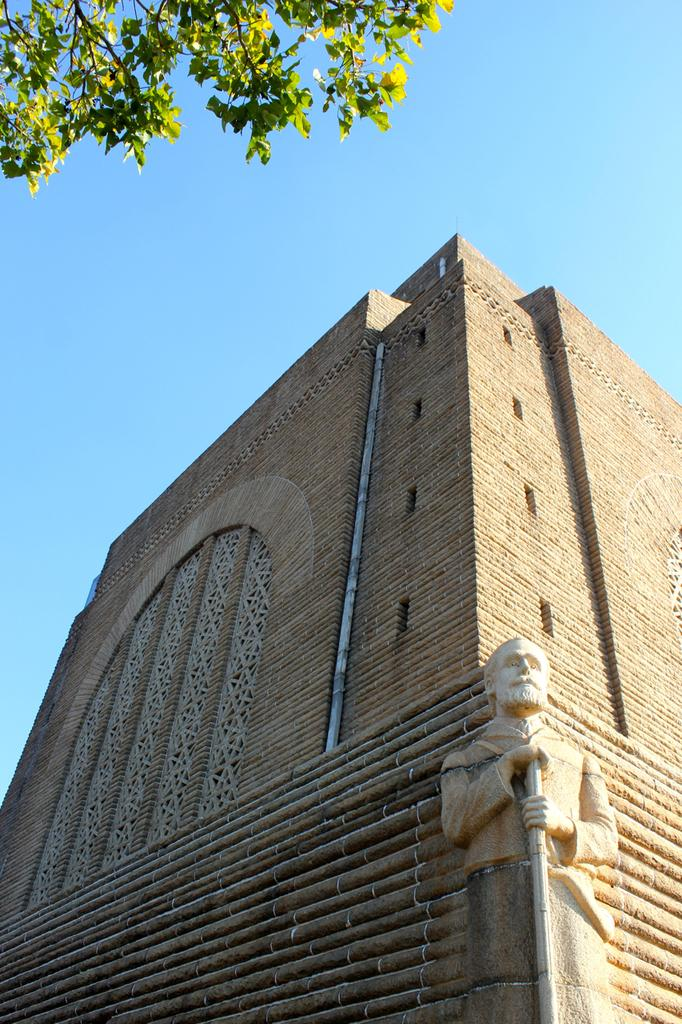What type of structure is present in the image? There is a building in the image. What decorative element can be seen on the building? There is a sculpture on the building. What is visible at the top of the image? The sky is visible at the top of the image. What type of vegetation is present in the image? There is a tree in the image. What type of lamp is used to illuminate the rice in the image? There is no lamp or rice present in the image. 